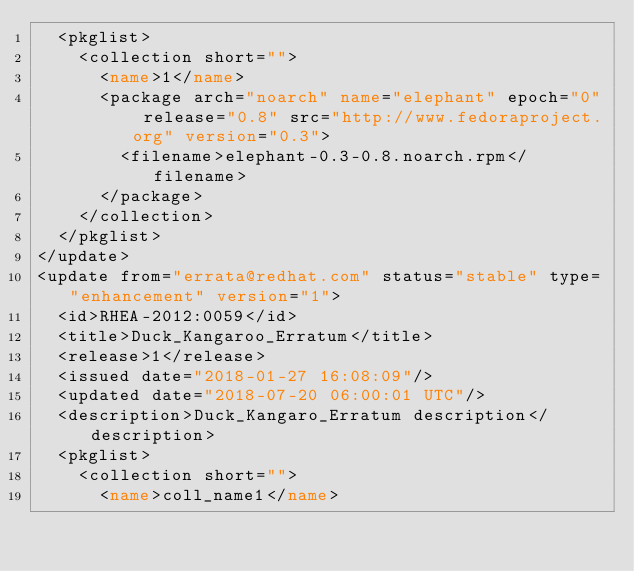Convert code to text. <code><loc_0><loc_0><loc_500><loc_500><_XML_>  <pkglist>
    <collection short="">
      <name>1</name>
      <package arch="noarch" name="elephant" epoch="0" release="0.8" src="http://www.fedoraproject.org" version="0.3">
        <filename>elephant-0.3-0.8.noarch.rpm</filename>
      </package>
    </collection>
  </pkglist>
</update>
<update from="errata@redhat.com" status="stable" type="enhancement" version="1">
  <id>RHEA-2012:0059</id>
  <title>Duck_Kangaroo_Erratum</title>
  <release>1</release>
  <issued date="2018-01-27 16:08:09"/>
  <updated date="2018-07-20 06:00:01 UTC"/>
  <description>Duck_Kangaro_Erratum description</description>
  <pkglist>
    <collection short="">
      <name>coll_name1</name></code> 